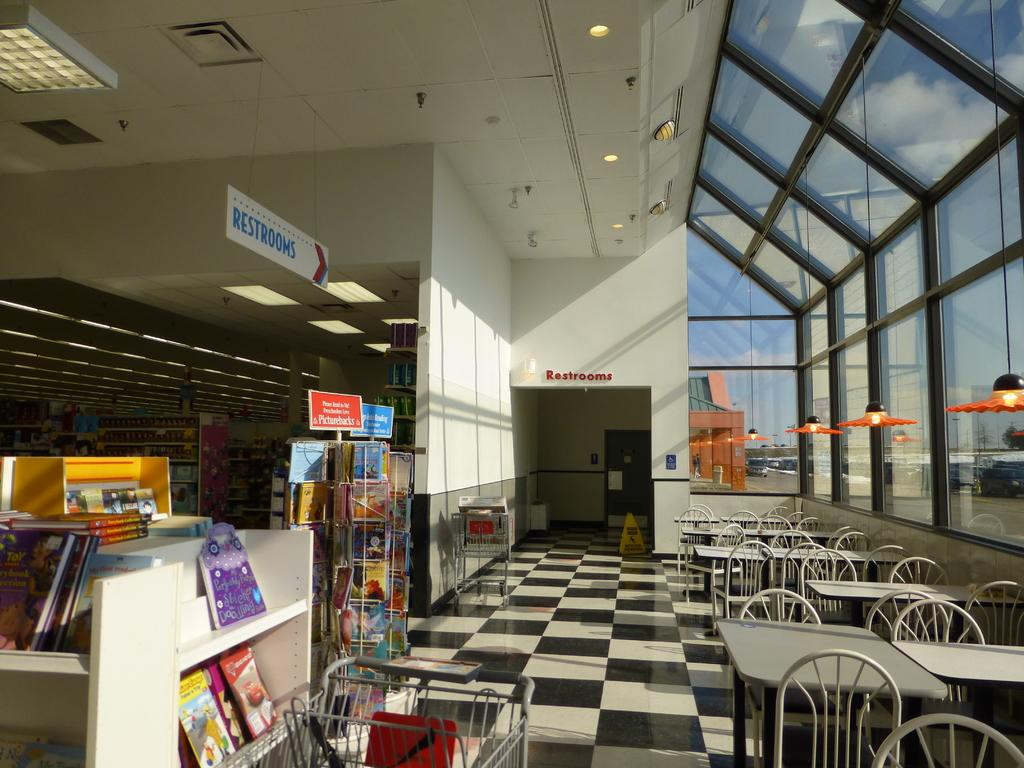<image>
Summarize the visual content of the image. A store with tables and chairs and two signs showing the way to the restrooms. 